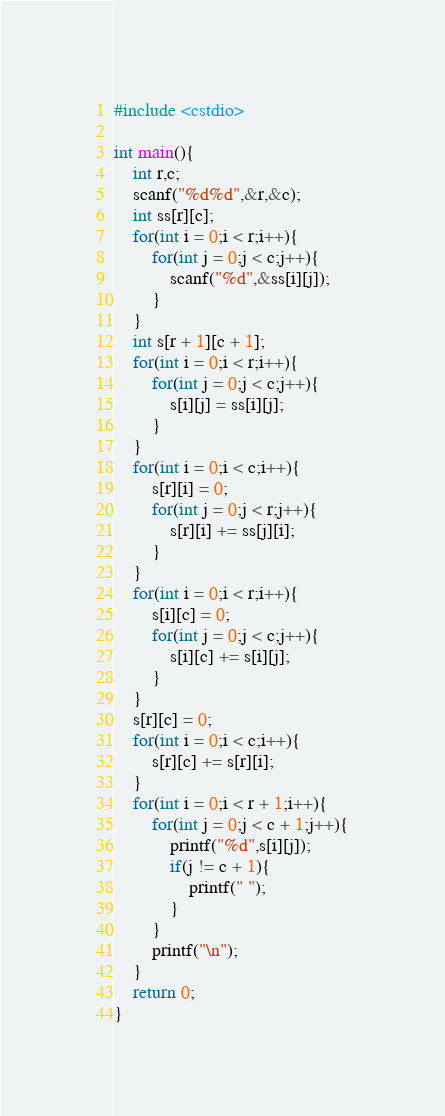Convert code to text. <code><loc_0><loc_0><loc_500><loc_500><_C++_>
#include <cstdio>

int main(){
    int r,c;
    scanf("%d%d",&r,&c);
    int ss[r][c];
    for(int i = 0;i < r;i++){
        for(int j = 0;j < c;j++){
            scanf("%d",&ss[i][j]);
        }
    }
    int s[r + 1][c + 1];
    for(int i = 0;i < r;i++){
        for(int j = 0;j < c;j++){
            s[i][j] = ss[i][j];
        }
    }
    for(int i = 0;i < c;i++){
        s[r][i] = 0;
        for(int j = 0;j < r;j++){
            s[r][i] += ss[j][i];
        }
    }
    for(int i = 0;i < r;i++){
        s[i][c] = 0;
        for(int j = 0;j < c;j++){
            s[i][c] += s[i][j];
        }
    }
    s[r][c] = 0;
    for(int i = 0;i < c;i++){
        s[r][c] += s[r][i];
    }
    for(int i = 0;i < r + 1;i++){
        for(int j = 0;j < c + 1;j++){
            printf("%d",s[i][j]);
            if(j != c + 1){
                printf(" ");
            }
        }
        printf("\n");
    }
    return 0;
}
</code> 